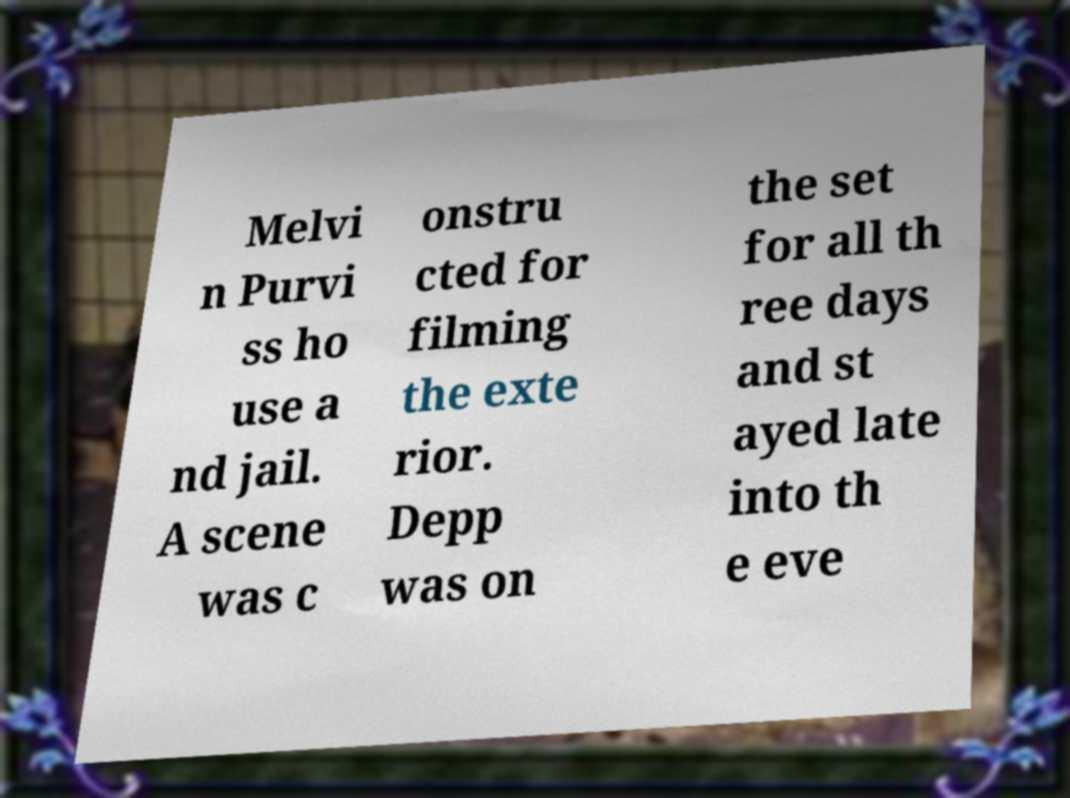I need the written content from this picture converted into text. Can you do that? Melvi n Purvi ss ho use a nd jail. A scene was c onstru cted for filming the exte rior. Depp was on the set for all th ree days and st ayed late into th e eve 